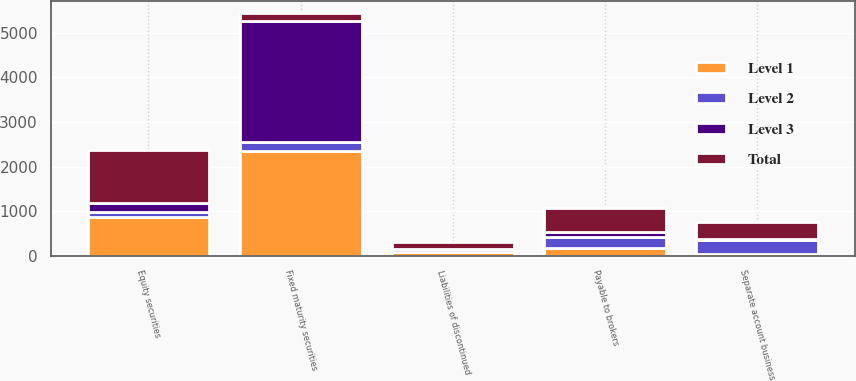Convert chart to OTSL. <chart><loc_0><loc_0><loc_500><loc_500><stacked_bar_chart><ecel><fcel>Fixed maturity securities<fcel>Equity securities<fcel>Separate account business<fcel>Payable to brokers<fcel>Liabilities of discontinued<nl><fcel>Level 1<fcel>2358<fcel>881<fcel>40<fcel>168<fcel>83<nl><fcel>Level 2<fcel>189<fcel>94<fcel>306<fcel>260<fcel>59<nl><fcel>Level 3<fcel>2710<fcel>210<fcel>38<fcel>112<fcel>15<nl><fcel>Total<fcel>189<fcel>1185<fcel>384<fcel>540<fcel>157<nl></chart> 